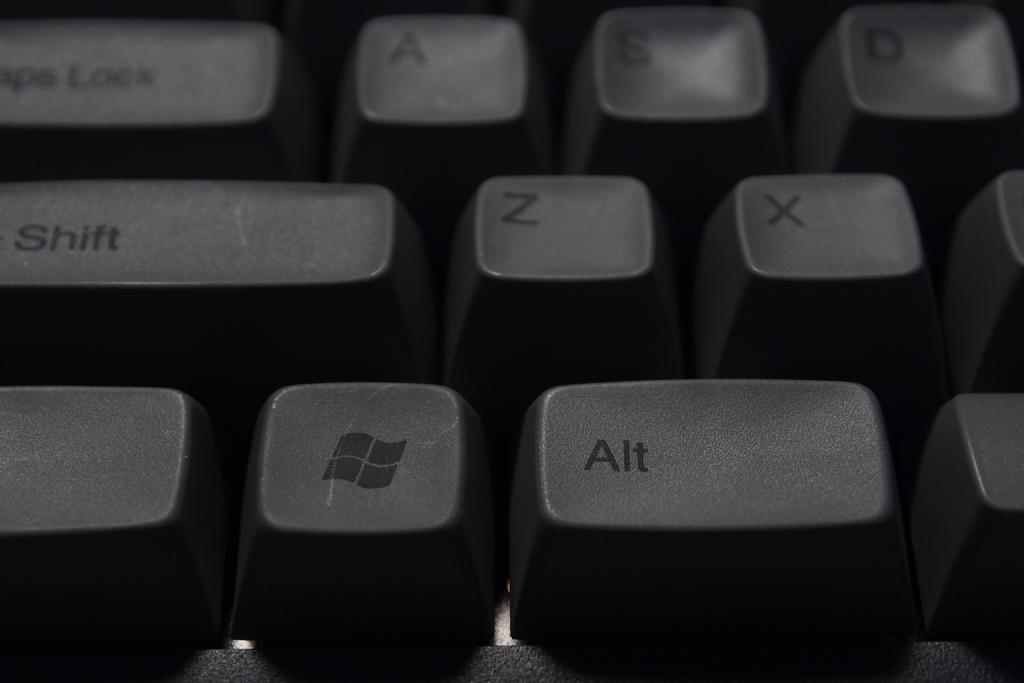Provide a one-sentence caption for the provided image. The black keyboard has the Microsoft windows symbol next to the alt key. 